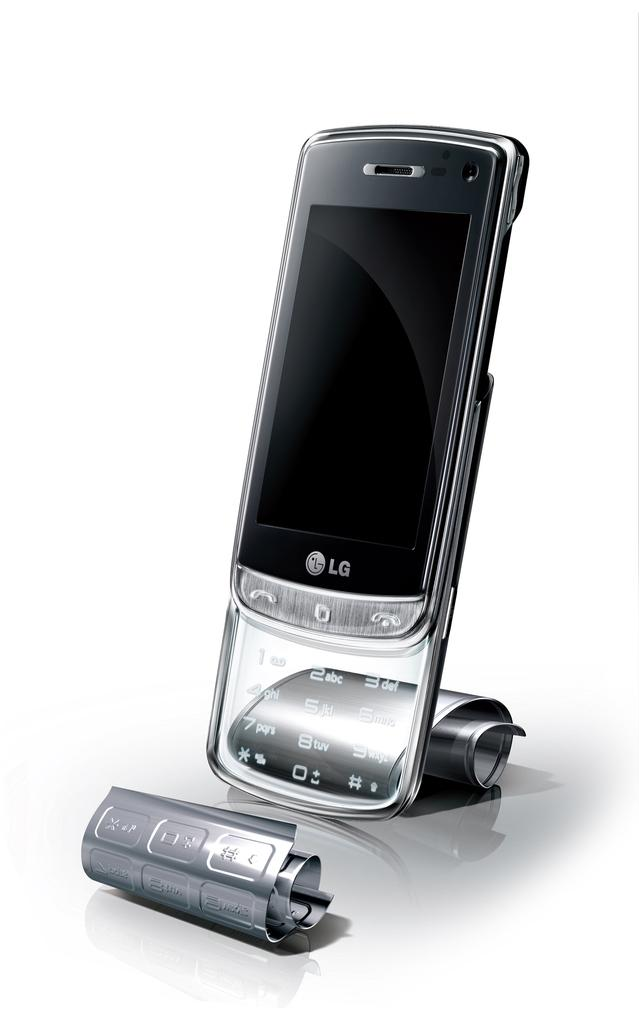<image>
Share a concise interpretation of the image provided. the letters LG on the phone someone has 